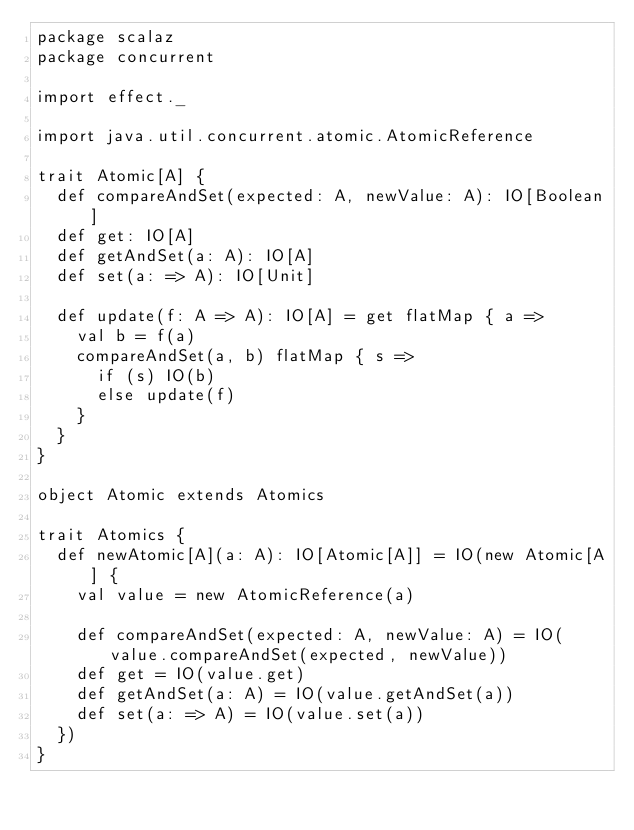<code> <loc_0><loc_0><loc_500><loc_500><_Scala_>package scalaz
package concurrent

import effect._

import java.util.concurrent.atomic.AtomicReference

trait Atomic[A] {
  def compareAndSet(expected: A, newValue: A): IO[Boolean]
  def get: IO[A]
  def getAndSet(a: A): IO[A]
  def set(a: => A): IO[Unit]

  def update(f: A => A): IO[A] = get flatMap { a =>
    val b = f(a)
    compareAndSet(a, b) flatMap { s =>
      if (s) IO(b)
      else update(f)
    }
  }
}

object Atomic extends Atomics

trait Atomics {
  def newAtomic[A](a: A): IO[Atomic[A]] = IO(new Atomic[A] {
    val value = new AtomicReference(a)

    def compareAndSet(expected: A, newValue: A) = IO(value.compareAndSet(expected, newValue))
    def get = IO(value.get)
    def getAndSet(a: A) = IO(value.getAndSet(a))
    def set(a: => A) = IO(value.set(a))
  })
}
</code> 